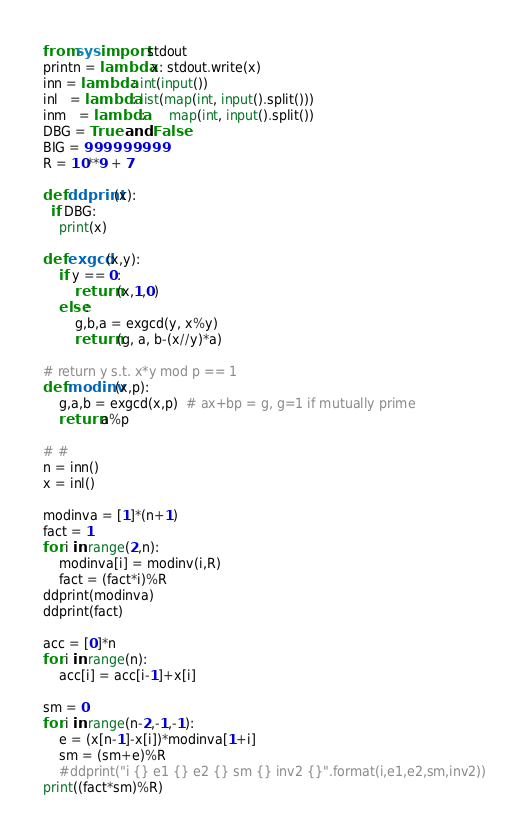Convert code to text. <code><loc_0><loc_0><loc_500><loc_500><_Python_>from sys import stdout
printn = lambda x: stdout.write(x)
inn = lambda : int(input())
inl   = lambda: list(map(int, input().split()))
inm   = lambda:      map(int, input().split())
DBG = True  and False
BIG = 999999999
R = 10**9 + 7

def ddprint(x):
  if DBG:
    print(x)

def exgcd(x,y):
    if y == 0:
        return (x,1,0)
    else:
        g,b,a = exgcd(y, x%y)
        return (g, a, b-(x//y)*a)

# return y s.t. x*y mod p == 1
def modinv(x,p):
    g,a,b = exgcd(x,p)  # ax+bp = g, g=1 if mutually prime
    return a%p

# #
n = inn()
x = inl()

modinva = [1]*(n+1)
fact = 1
for i in range(2,n):
    modinva[i] = modinv(i,R)
    fact = (fact*i)%R
ddprint(modinva)
ddprint(fact)

acc = [0]*n
for i in range(n):
    acc[i] = acc[i-1]+x[i]

sm = 0
for i in range(n-2,-1,-1):
    e = (x[n-1]-x[i])*modinva[1+i]
    sm = (sm+e)%R
    #ddprint("i {} e1 {} e2 {} sm {} inv2 {}".format(i,e1,e2,sm,inv2))
print((fact*sm)%R)
</code> 